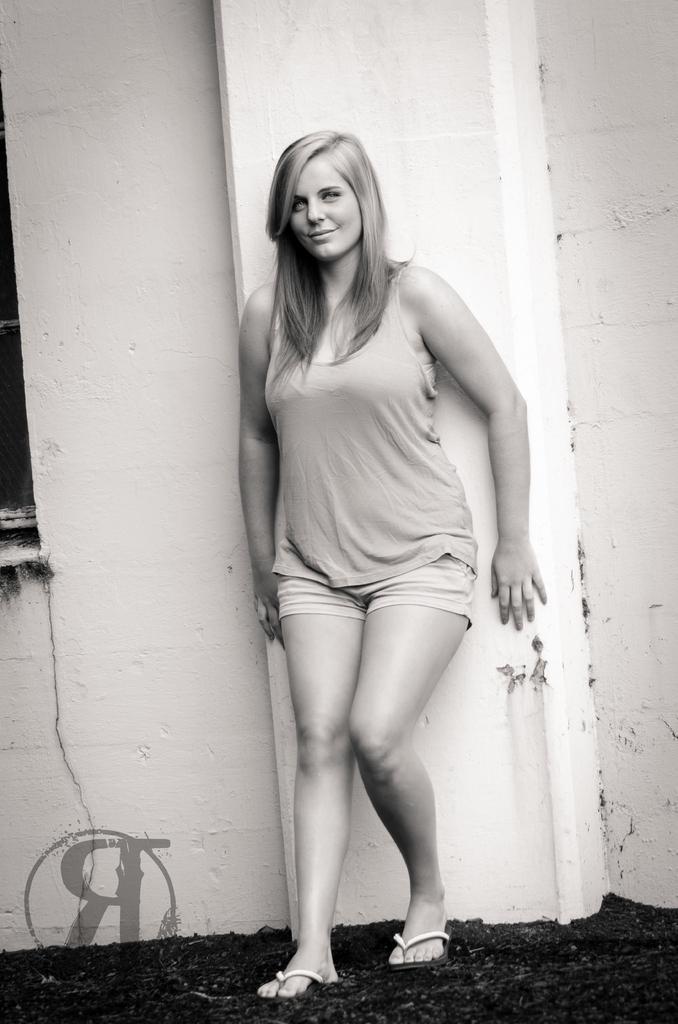How would you summarize this image in a sentence or two? In the image a woman is standing and smiling. Behind her there is wall. 